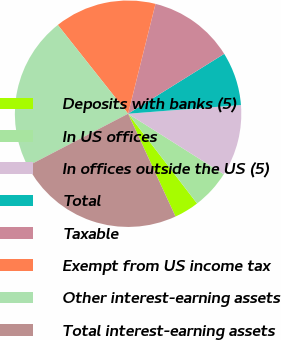Convert chart to OTSL. <chart><loc_0><loc_0><loc_500><loc_500><pie_chart><fcel>Deposits with banks (5)<fcel>In US offices<fcel>In offices outside the US (5)<fcel>Total<fcel>Taxable<fcel>Exempt from US income tax<fcel>Other interest-earning assets<fcel>Total interest-earning assets<nl><fcel>3.55%<fcel>5.6%<fcel>10.2%<fcel>7.64%<fcel>12.24%<fcel>14.55%<fcel>21.99%<fcel>24.23%<nl></chart> 